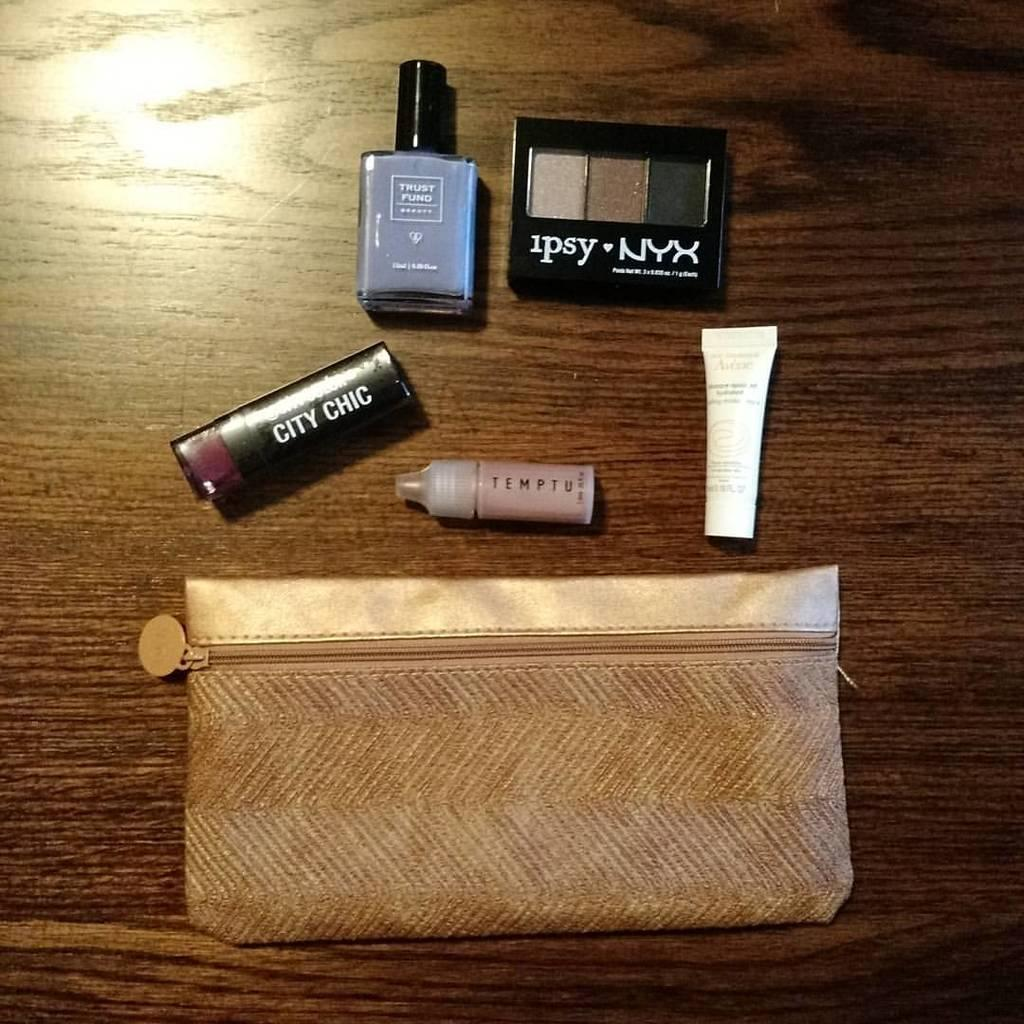<image>
Present a compact description of the photo's key features. Makeup out of the bag on the table including City Chic & Temptu. 